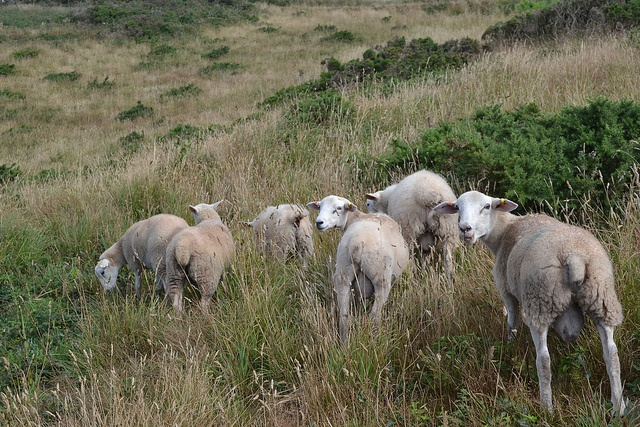Describe the objects in this image and their specific colors. I can see sheep in gray, darkgray, black, and lightgray tones, sheep in gray, darkgray, and lightgray tones, sheep in gray, darkgray, and tan tones, sheep in gray, darkgray, and lightgray tones, and sheep in gray, darkgray, and black tones in this image. 